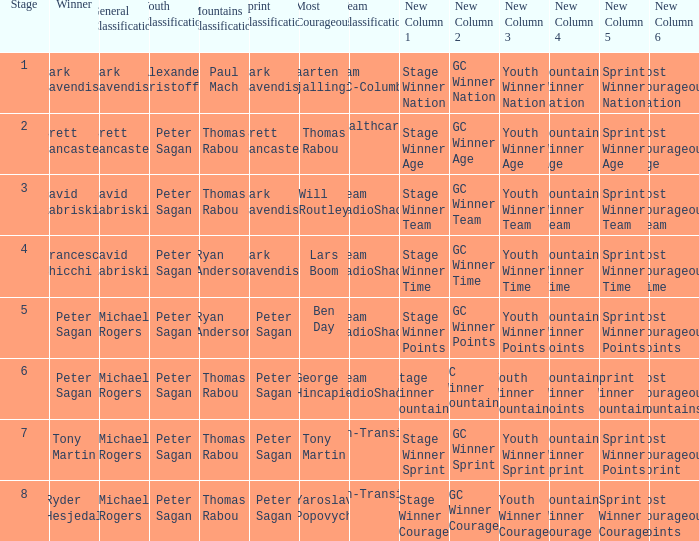Who won the mountains classification when Maarten Tjallingii won most corageous? Paul Mach. 